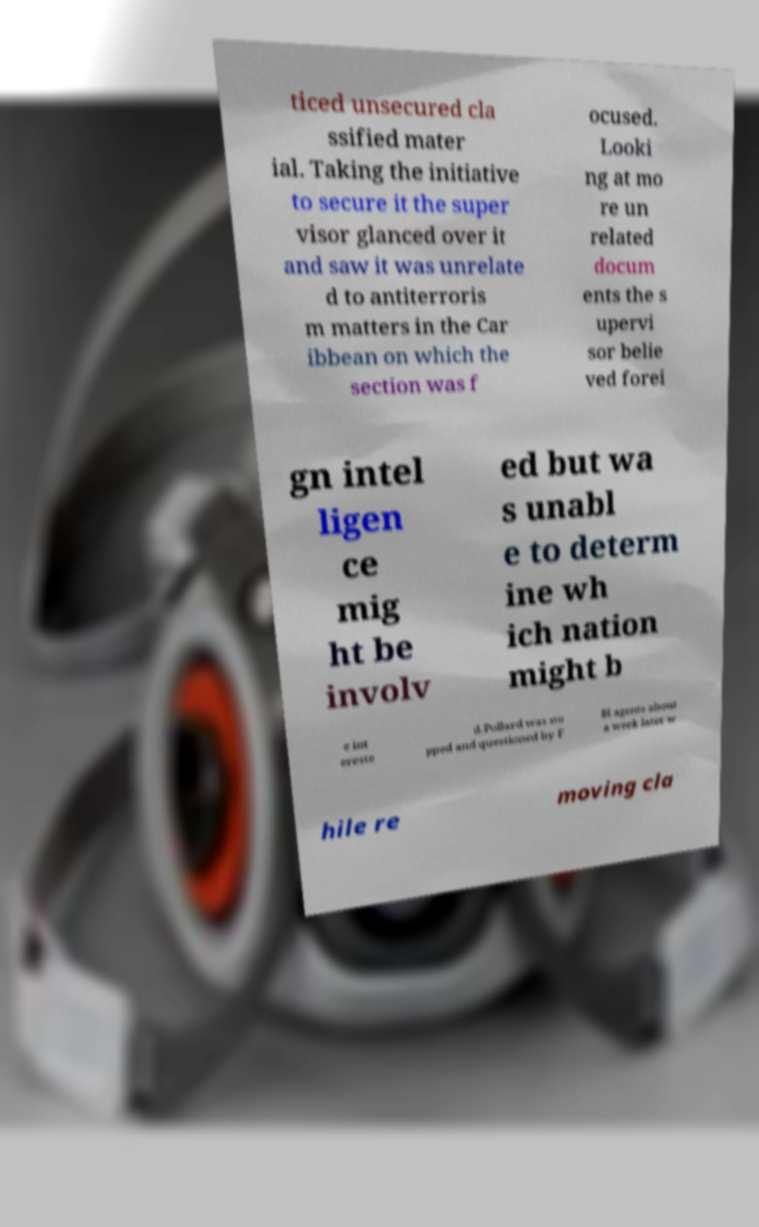Please read and relay the text visible in this image. What does it say? ticed unsecured cla ssified mater ial. Taking the initiative to secure it the super visor glanced over it and saw it was unrelate d to antiterroris m matters in the Car ibbean on which the section was f ocused. Looki ng at mo re un related docum ents the s upervi sor belie ved forei gn intel ligen ce mig ht be involv ed but wa s unabl e to determ ine wh ich nation might b e int ereste d.Pollard was sto pped and questioned by F BI agents about a week later w hile re moving cla 